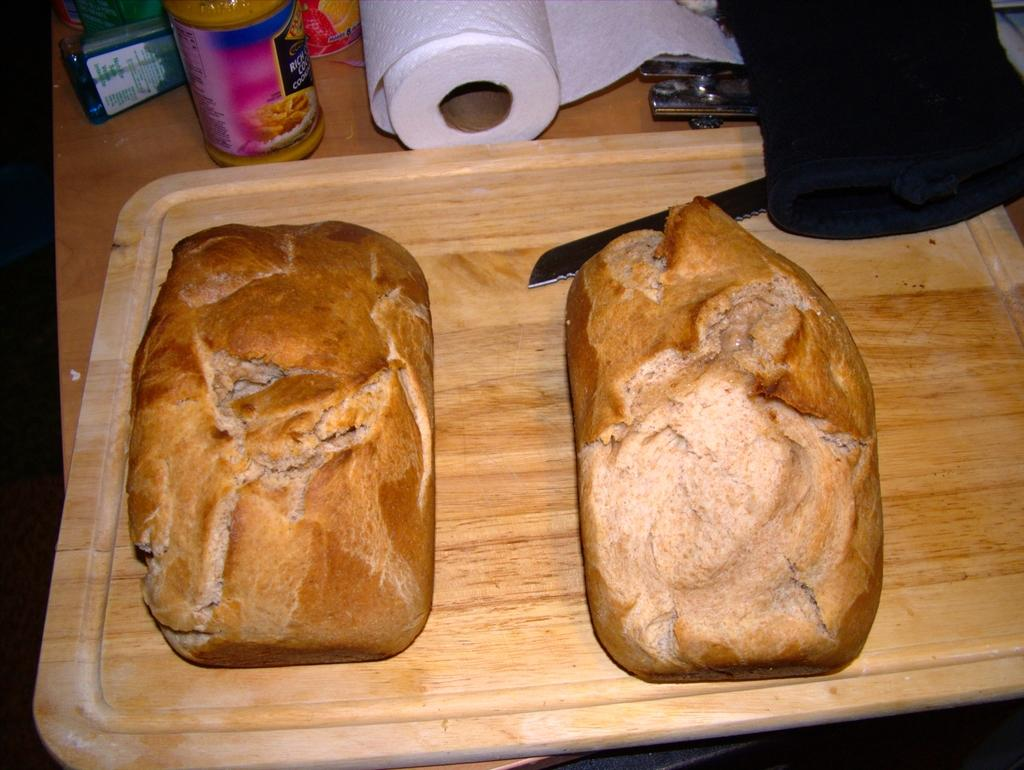What is the main piece of furniture in the image? There is a table in the image. What is placed on the table? The table has a tray on it. What is inside the tray? The tray contains buns, a knife, a tissue roll, and bottles. Are there any other objects in the tray? Yes, there are other objects in the tray. Can you see any wine being poured from a bottle in the image? There is no wine or bottle being poured in the image. Is there a cat sitting on the table in the image? There is no cat present in the image. 